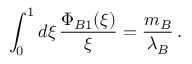Convert formula to latex. <formula><loc_0><loc_0><loc_500><loc_500>\int _ { 0 } ^ { 1 } d \xi \, \frac { \Phi _ { B 1 } ( \xi ) } { \xi } = \frac { m _ { B } } { \lambda _ { B } } \, .</formula> 